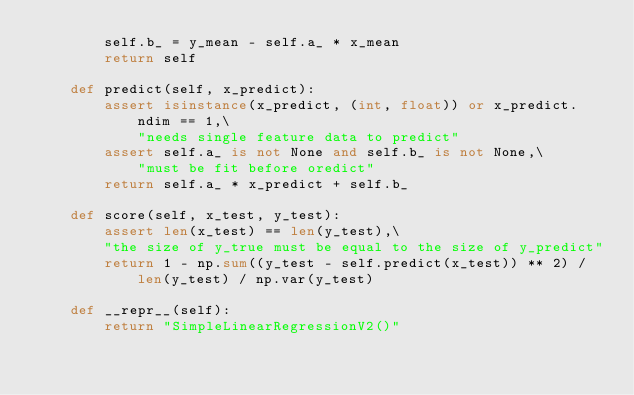Convert code to text. <code><loc_0><loc_0><loc_500><loc_500><_Python_>        self.b_ = y_mean - self.a_ * x_mean
        return self

    def predict(self, x_predict):
        assert isinstance(x_predict, (int, float)) or x_predict.ndim == 1,\
            "needs single feature data to predict"
        assert self.a_ is not None and self.b_ is not None,\
            "must be fit before oredict"
        return self.a_ * x_predict + self.b_

    def score(self, x_test, y_test):
        assert len(x_test) == len(y_test),\
        "the size of y_true must be equal to the size of y_predict"
        return 1 - np.sum((y_test - self.predict(x_test)) ** 2) / len(y_test) / np.var(y_test)

    def __repr__(self):
        return "SimpleLinearRegressionV2()"</code> 